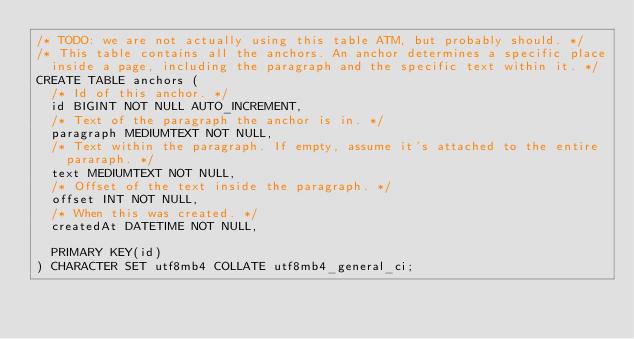<code> <loc_0><loc_0><loc_500><loc_500><_SQL_>/* TODO: we are not actually using this table ATM, but probably should. */
/* This table contains all the anchors. An anchor determines a specific place
	inside a page, including the paragraph and the specific text within it. */
CREATE TABLE anchors (
	/* Id of this anchor. */
	id BIGINT NOT NULL AUTO_INCREMENT,
	/* Text of the paragraph the anchor is in. */
	paragraph MEDIUMTEXT NOT NULL,
	/* Text within the paragraph. If empty, assume it's attached to the entire
		pararaph. */
	text MEDIUMTEXT NOT NULL,
	/* Offset of the text inside the paragraph. */
	offset INT NOT NULL,
	/* When this was created. */
	createdAt DATETIME NOT NULL,

	PRIMARY KEY(id)
) CHARACTER SET utf8mb4 COLLATE utf8mb4_general_ci;
</code> 